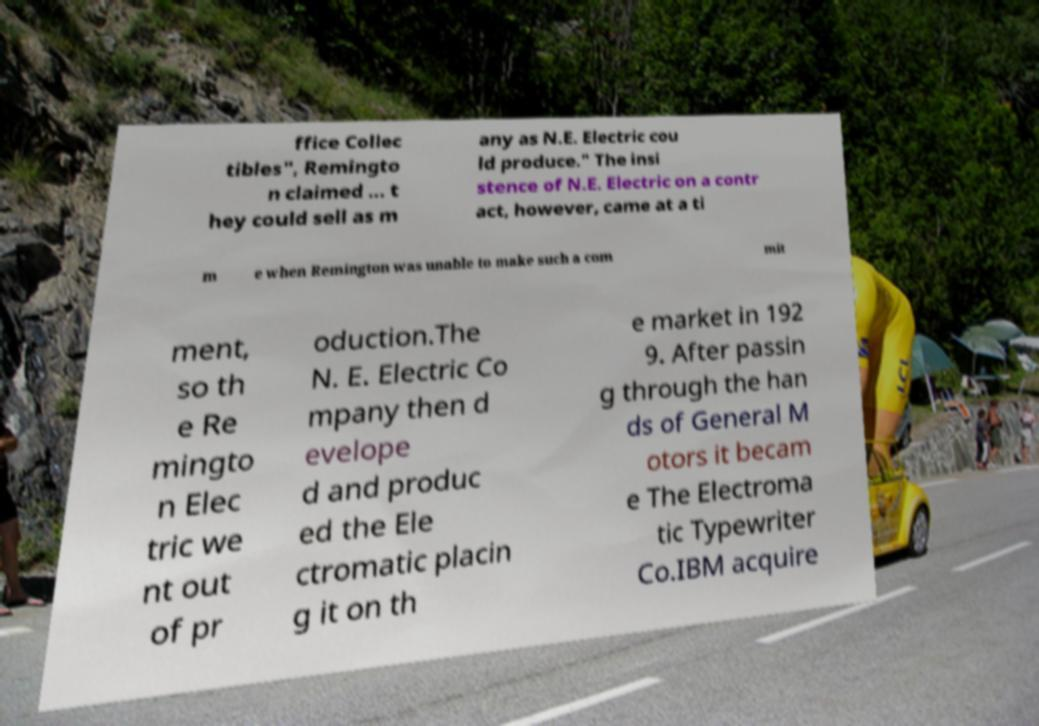Can you accurately transcribe the text from the provided image for me? ffice Collec tibles", Remingto n claimed ... t hey could sell as m any as N.E. Electric cou ld produce." The insi stence of N.E. Electric on a contr act, however, came at a ti m e when Remington was unable to make such a com mit ment, so th e Re mingto n Elec tric we nt out of pr oduction.The N. E. Electric Co mpany then d evelope d and produc ed the Ele ctromatic placin g it on th e market in 192 9. After passin g through the han ds of General M otors it becam e The Electroma tic Typewriter Co.IBM acquire 